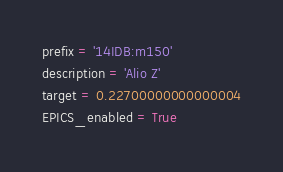Convert code to text. <code><loc_0><loc_0><loc_500><loc_500><_Python_>prefix = '14IDB:m150'
description = 'Alio Z'
target = 0.22700000000000004
EPICS_enabled = True</code> 